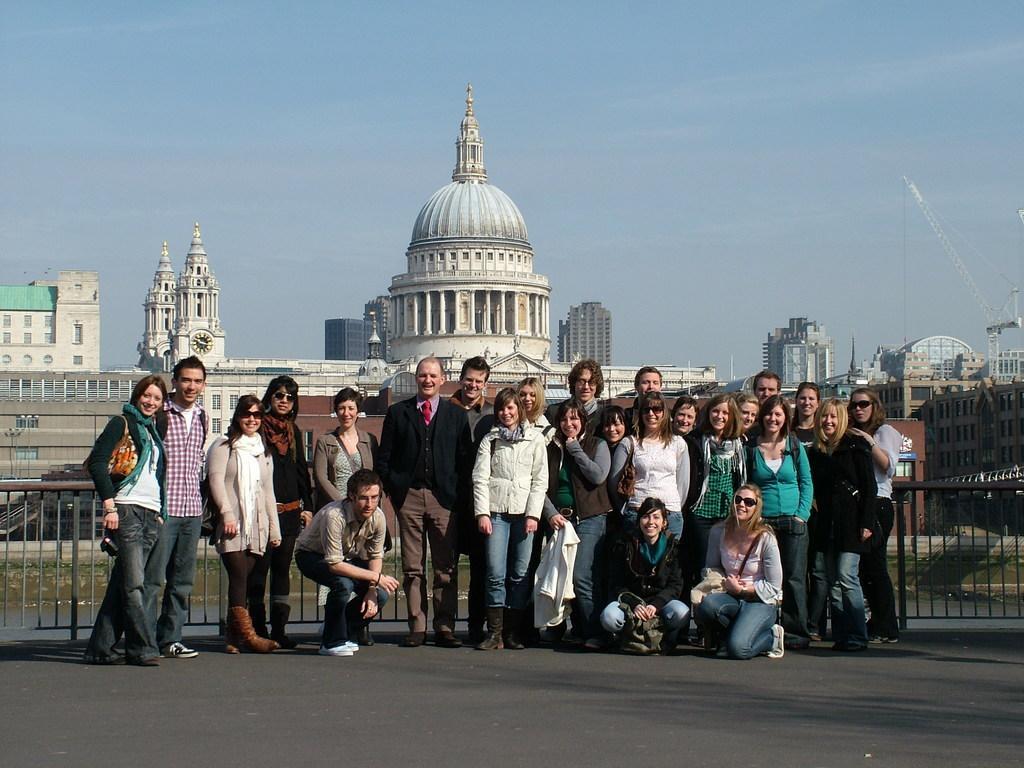Describe this image in one or two sentences. In this image there are some persons standing as we can see in the bottom of this image. There is a fencing in the background. There are some buildings with some tombs on the back side to these persons. There is a sky on the top of this image. There is a crane on the right side of this image. 